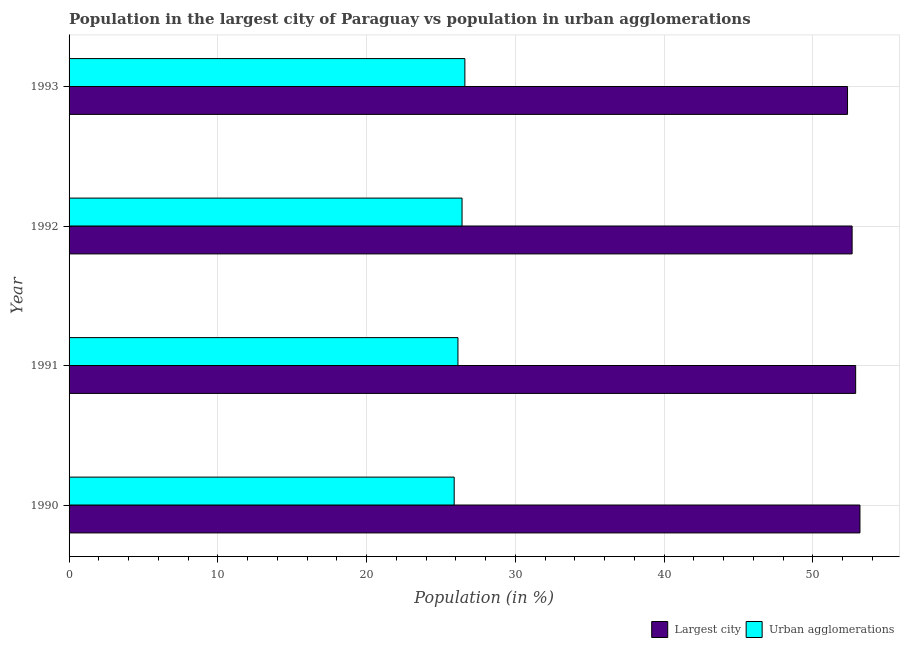How many different coloured bars are there?
Provide a succinct answer. 2. How many groups of bars are there?
Your response must be concise. 4. Are the number of bars on each tick of the Y-axis equal?
Your response must be concise. Yes. How many bars are there on the 4th tick from the top?
Make the answer very short. 2. How many bars are there on the 2nd tick from the bottom?
Provide a succinct answer. 2. What is the label of the 4th group of bars from the top?
Your answer should be compact. 1990. In how many cases, is the number of bars for a given year not equal to the number of legend labels?
Offer a very short reply. 0. What is the population in the largest city in 1990?
Provide a short and direct response. 53.16. Across all years, what is the maximum population in urban agglomerations?
Offer a very short reply. 26.6. Across all years, what is the minimum population in urban agglomerations?
Your answer should be very brief. 25.88. In which year was the population in the largest city maximum?
Offer a very short reply. 1990. In which year was the population in urban agglomerations minimum?
Keep it short and to the point. 1990. What is the total population in the largest city in the graph?
Your answer should be compact. 210.98. What is the difference between the population in urban agglomerations in 1991 and that in 1993?
Provide a succinct answer. -0.47. What is the difference between the population in the largest city in 1993 and the population in urban agglomerations in 1991?
Give a very brief answer. 26.18. What is the average population in the largest city per year?
Give a very brief answer. 52.74. In the year 1990, what is the difference between the population in urban agglomerations and population in the largest city?
Your answer should be very brief. -27.27. Is the difference between the population in urban agglomerations in 1992 and 1993 greater than the difference between the population in the largest city in 1992 and 1993?
Provide a short and direct response. No. What is the difference between the highest and the second highest population in urban agglomerations?
Give a very brief answer. 0.19. What is the difference between the highest and the lowest population in the largest city?
Your answer should be compact. 0.84. What does the 2nd bar from the top in 1991 represents?
Offer a very short reply. Largest city. What does the 2nd bar from the bottom in 1993 represents?
Provide a short and direct response. Urban agglomerations. Are all the bars in the graph horizontal?
Offer a very short reply. Yes. How many years are there in the graph?
Your answer should be very brief. 4. Does the graph contain any zero values?
Keep it short and to the point. No. Where does the legend appear in the graph?
Offer a very short reply. Bottom right. What is the title of the graph?
Offer a terse response. Population in the largest city of Paraguay vs population in urban agglomerations. What is the label or title of the Y-axis?
Make the answer very short. Year. What is the Population (in %) in Largest city in 1990?
Your answer should be very brief. 53.16. What is the Population (in %) of Urban agglomerations in 1990?
Your answer should be compact. 25.88. What is the Population (in %) in Largest city in 1991?
Give a very brief answer. 52.87. What is the Population (in %) of Urban agglomerations in 1991?
Provide a succinct answer. 26.14. What is the Population (in %) of Largest city in 1992?
Offer a very short reply. 52.63. What is the Population (in %) of Urban agglomerations in 1992?
Keep it short and to the point. 26.41. What is the Population (in %) of Largest city in 1993?
Keep it short and to the point. 52.32. What is the Population (in %) of Urban agglomerations in 1993?
Provide a succinct answer. 26.6. Across all years, what is the maximum Population (in %) in Largest city?
Your answer should be very brief. 53.16. Across all years, what is the maximum Population (in %) in Urban agglomerations?
Offer a terse response. 26.6. Across all years, what is the minimum Population (in %) in Largest city?
Provide a short and direct response. 52.32. Across all years, what is the minimum Population (in %) in Urban agglomerations?
Give a very brief answer. 25.88. What is the total Population (in %) of Largest city in the graph?
Your answer should be compact. 210.98. What is the total Population (in %) in Urban agglomerations in the graph?
Ensure brevity in your answer.  105.04. What is the difference between the Population (in %) of Largest city in 1990 and that in 1991?
Provide a succinct answer. 0.29. What is the difference between the Population (in %) in Urban agglomerations in 1990 and that in 1991?
Your response must be concise. -0.25. What is the difference between the Population (in %) in Largest city in 1990 and that in 1992?
Make the answer very short. 0.53. What is the difference between the Population (in %) in Urban agglomerations in 1990 and that in 1992?
Your response must be concise. -0.53. What is the difference between the Population (in %) of Largest city in 1990 and that in 1993?
Offer a very short reply. 0.84. What is the difference between the Population (in %) of Urban agglomerations in 1990 and that in 1993?
Provide a short and direct response. -0.72. What is the difference between the Population (in %) in Largest city in 1991 and that in 1992?
Ensure brevity in your answer.  0.24. What is the difference between the Population (in %) in Urban agglomerations in 1991 and that in 1992?
Your answer should be very brief. -0.28. What is the difference between the Population (in %) of Largest city in 1991 and that in 1993?
Your answer should be compact. 0.55. What is the difference between the Population (in %) of Urban agglomerations in 1991 and that in 1993?
Provide a succinct answer. -0.47. What is the difference between the Population (in %) of Largest city in 1992 and that in 1993?
Provide a short and direct response. 0.31. What is the difference between the Population (in %) in Urban agglomerations in 1992 and that in 1993?
Offer a very short reply. -0.19. What is the difference between the Population (in %) in Largest city in 1990 and the Population (in %) in Urban agglomerations in 1991?
Provide a short and direct response. 27.02. What is the difference between the Population (in %) of Largest city in 1990 and the Population (in %) of Urban agglomerations in 1992?
Provide a succinct answer. 26.74. What is the difference between the Population (in %) of Largest city in 1990 and the Population (in %) of Urban agglomerations in 1993?
Offer a terse response. 26.55. What is the difference between the Population (in %) of Largest city in 1991 and the Population (in %) of Urban agglomerations in 1992?
Provide a succinct answer. 26.46. What is the difference between the Population (in %) of Largest city in 1991 and the Population (in %) of Urban agglomerations in 1993?
Make the answer very short. 26.27. What is the difference between the Population (in %) of Largest city in 1992 and the Population (in %) of Urban agglomerations in 1993?
Give a very brief answer. 26.03. What is the average Population (in %) of Largest city per year?
Your answer should be compact. 52.75. What is the average Population (in %) of Urban agglomerations per year?
Keep it short and to the point. 26.26. In the year 1990, what is the difference between the Population (in %) of Largest city and Population (in %) of Urban agglomerations?
Your response must be concise. 27.27. In the year 1991, what is the difference between the Population (in %) of Largest city and Population (in %) of Urban agglomerations?
Your answer should be very brief. 26.73. In the year 1992, what is the difference between the Population (in %) of Largest city and Population (in %) of Urban agglomerations?
Provide a succinct answer. 26.22. In the year 1993, what is the difference between the Population (in %) in Largest city and Population (in %) in Urban agglomerations?
Your answer should be very brief. 25.72. What is the ratio of the Population (in %) in Urban agglomerations in 1990 to that in 1991?
Ensure brevity in your answer.  0.99. What is the ratio of the Population (in %) in Urban agglomerations in 1990 to that in 1992?
Your answer should be compact. 0.98. What is the ratio of the Population (in %) of Largest city in 1991 to that in 1992?
Provide a succinct answer. 1. What is the ratio of the Population (in %) in Urban agglomerations in 1991 to that in 1992?
Give a very brief answer. 0.99. What is the ratio of the Population (in %) of Largest city in 1991 to that in 1993?
Make the answer very short. 1.01. What is the ratio of the Population (in %) in Urban agglomerations in 1991 to that in 1993?
Make the answer very short. 0.98. What is the ratio of the Population (in %) of Largest city in 1992 to that in 1993?
Your answer should be very brief. 1.01. What is the ratio of the Population (in %) of Urban agglomerations in 1992 to that in 1993?
Offer a terse response. 0.99. What is the difference between the highest and the second highest Population (in %) in Largest city?
Your answer should be very brief. 0.29. What is the difference between the highest and the second highest Population (in %) in Urban agglomerations?
Keep it short and to the point. 0.19. What is the difference between the highest and the lowest Population (in %) in Largest city?
Offer a very short reply. 0.84. What is the difference between the highest and the lowest Population (in %) of Urban agglomerations?
Your answer should be very brief. 0.72. 